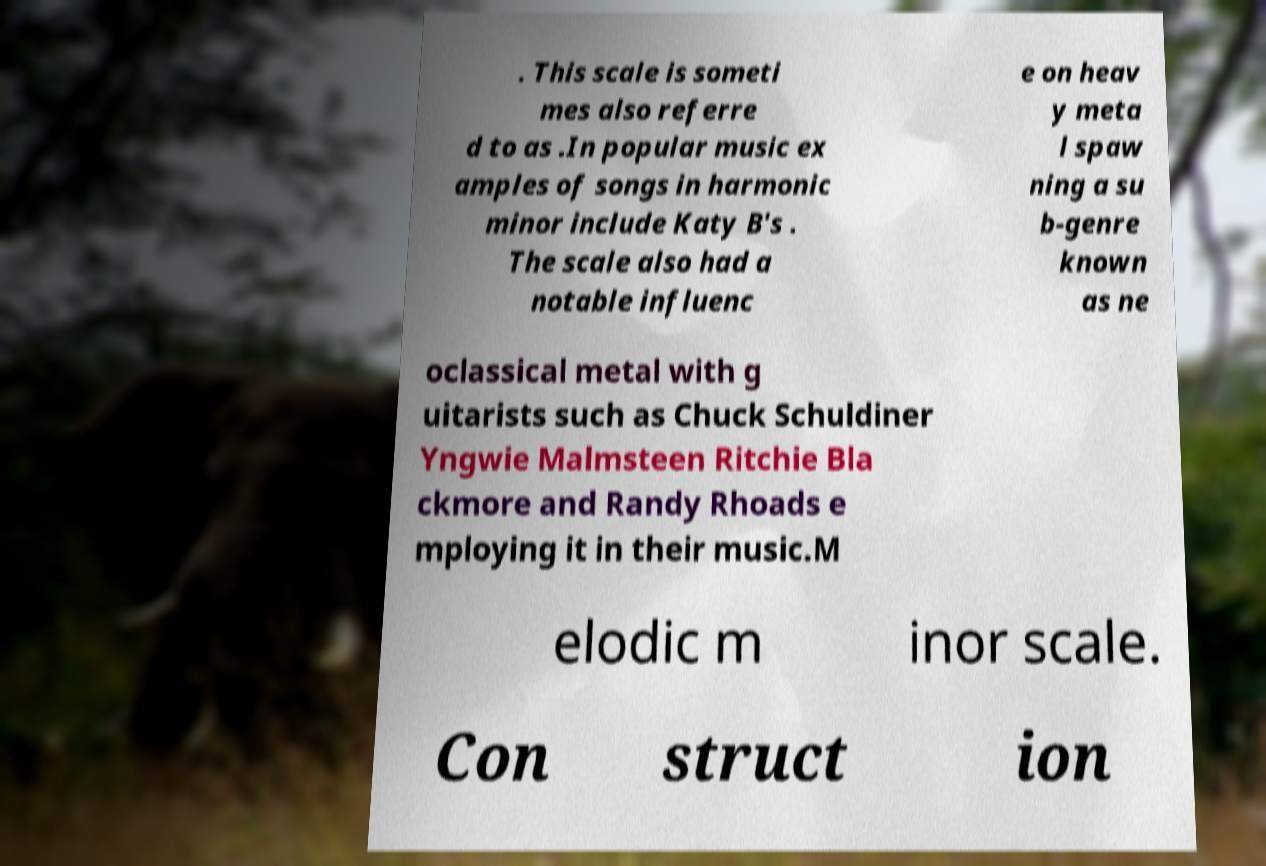What messages or text are displayed in this image? I need them in a readable, typed format. . This scale is someti mes also referre d to as .In popular music ex amples of songs in harmonic minor include Katy B's . The scale also had a notable influenc e on heav y meta l spaw ning a su b-genre known as ne oclassical metal with g uitarists such as Chuck Schuldiner Yngwie Malmsteen Ritchie Bla ckmore and Randy Rhoads e mploying it in their music.M elodic m inor scale. Con struct ion 